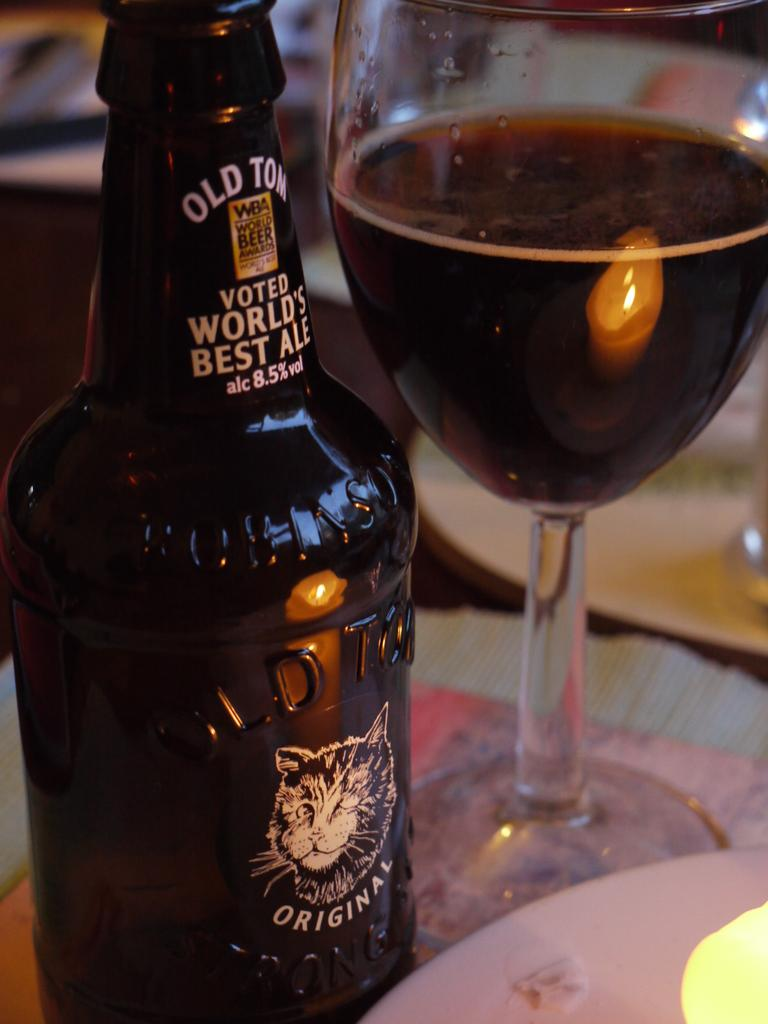<image>
Share a concise interpretation of the image provided. Old Tom which has 8.5 percent alcohol by volume was voted the world's best ale. 